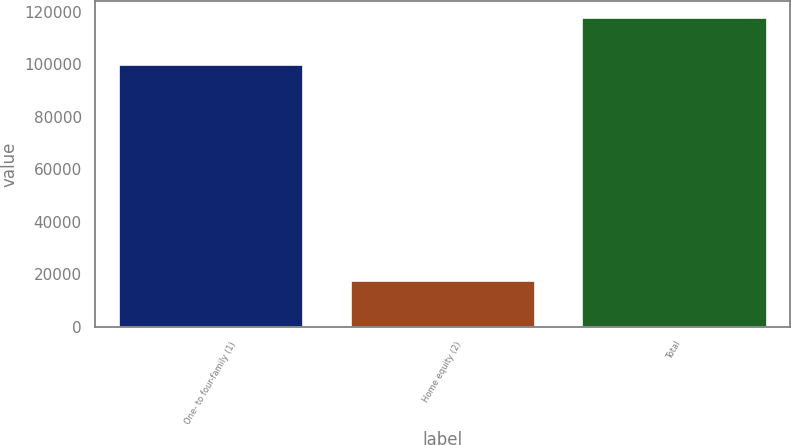Convert chart to OTSL. <chart><loc_0><loc_0><loc_500><loc_500><bar_chart><fcel>One- to four-family (1)<fcel>Home equity (2)<fcel>Total<nl><fcel>100182<fcel>17809<fcel>117991<nl></chart> 